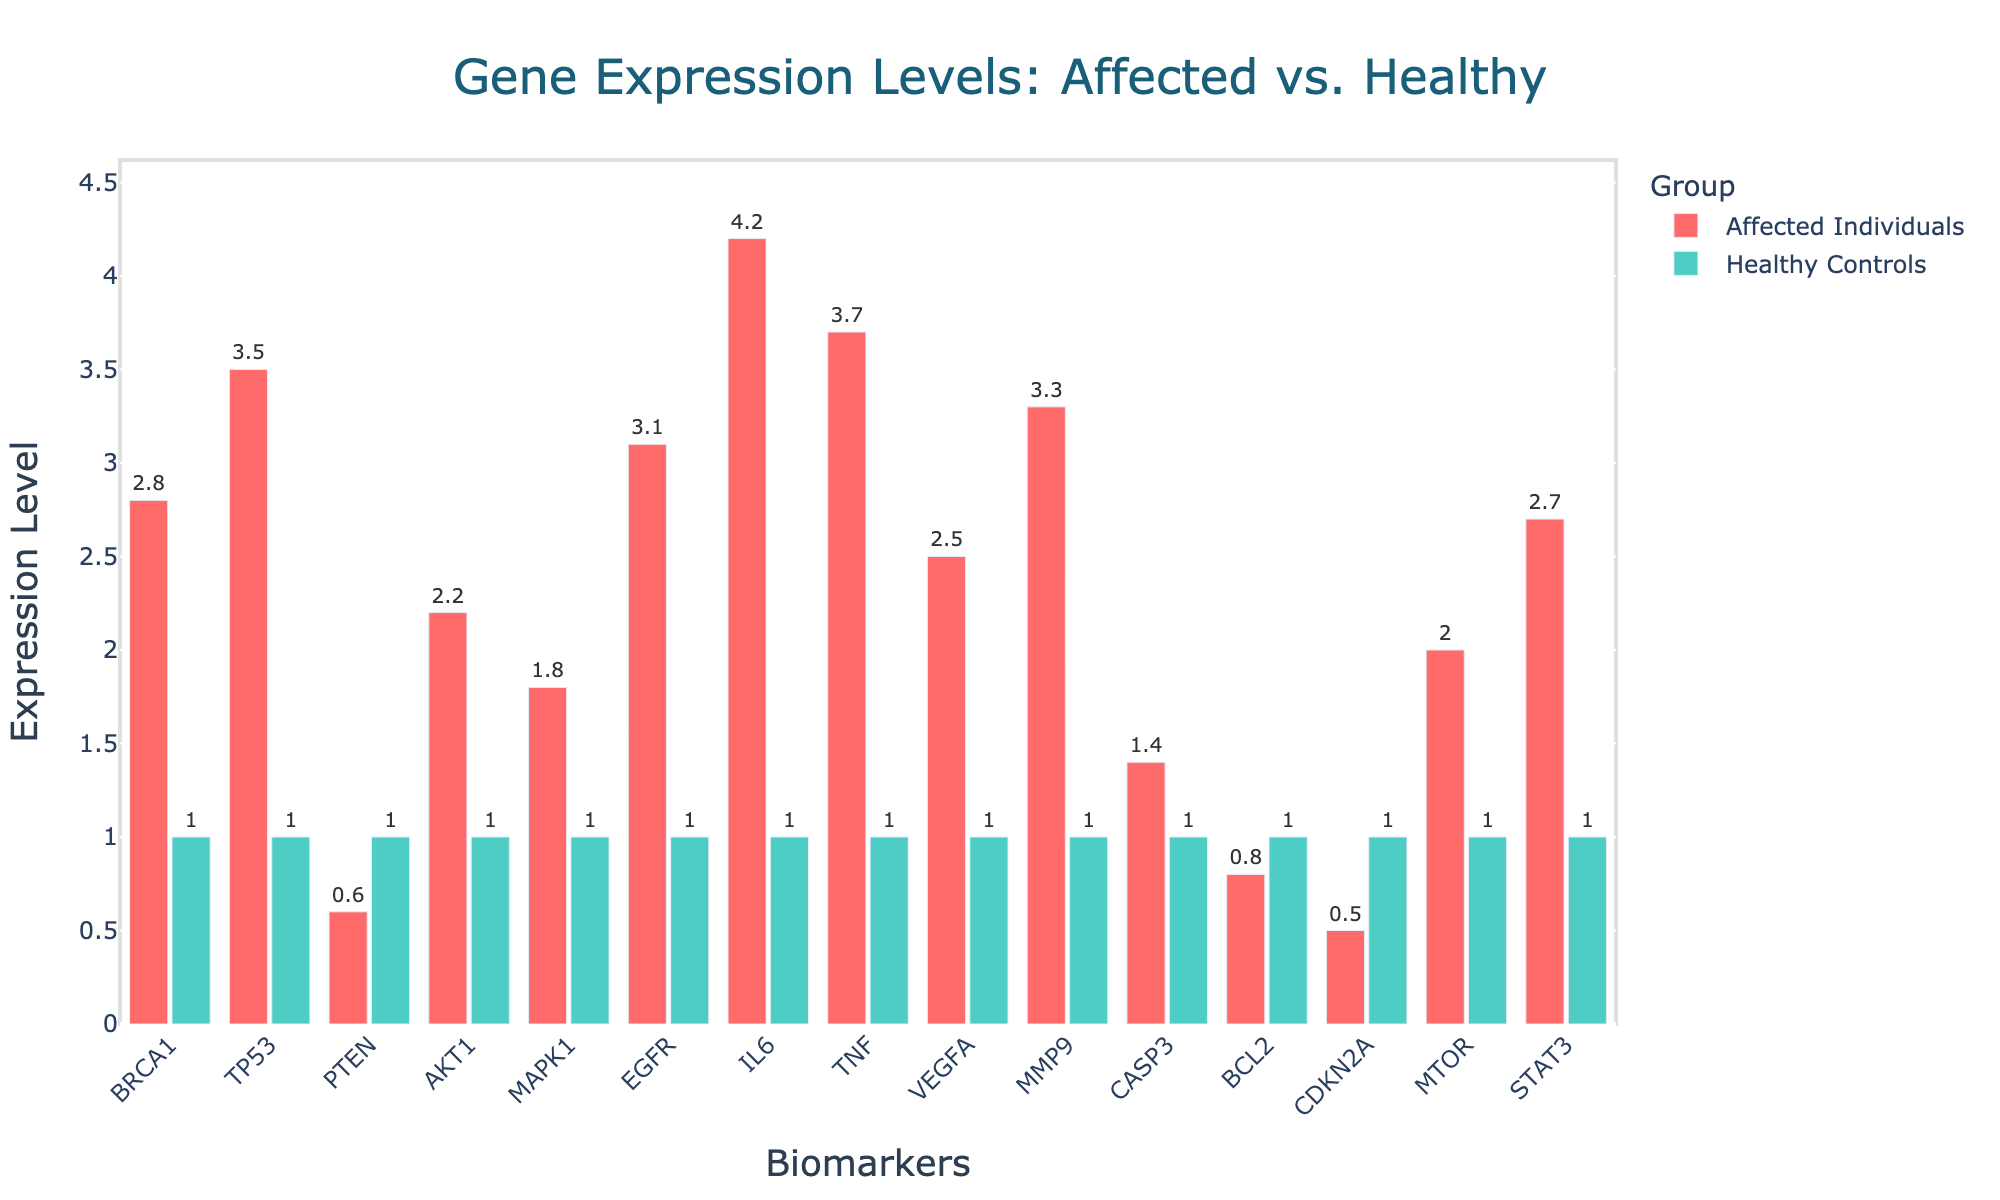What is the difference in gene expression levels of BRCA1 between affected individuals and healthy controls? The gene expression level for BRCA1 in affected individuals is 2.8, while in healthy controls it is 1.0. The difference is 2.8 - 1.0 = 1.8
Answer: 1.8 Which biomarker shows the highest gene expression level in affected individuals? By examining the heights of the bars representing affected individuals, IL6 has the highest bar corresponding to a gene expression level of 4.2
Answer: IL6 Are there any biomarkers where the gene expression level in healthy controls is higher than in affected individuals? By observing all the bars, PTEN (0.6 < 1.0), BCL2 (0.8 < 1.0), and CDKN2A (0.5 < 1.0) are biomarkers where the gene expression is higher in healthy controls
Answer: PTEN, BCL2, CDKN2A By how much does the gene expression level of EGFR in affected individuals exceed that in healthy controls? The gene expression level for EGFR in affected individuals is 3.1 while it is 1.0 in healthy controls. The excess is 3.1 - 1.0 = 2.1
Answer: 2.1 Which group has a more uniform gene expression level across the biomarkers, and how can you tell? The healthy controls show a more uniform gene expression level across the biomarkers because all bars for healthy controls are at the same height of 1.0, in contrast to the variable heights in affected individuals
Answer: Healthy controls What is the average gene expression level for biomarkers AKT1 and STAT3 in affected individuals? The gene expression levels for AKT1 and STAT3 are 2.2 and 2.7 respectively. The average is calculated as (2.2 + 2.7) / 2 = 2.45
Answer: 2.45 How many biomarkers have a gene expression level of at least 3.0 in affected individuals? By counting the bars that reach or exceed the height corresponding to 3.0, there are five biomarkers: TP53, EGFR, IL6, TNF, and MMP9
Answer: 5 Which biomarker shows the greatest decrease in gene expression levels when comparing affected individuals to healthy controls? By assessing the decrease, CDKN2A shows the greatest decrease as its value drops from 1.0 in healthy controls to 0.5 in affected individuals, a difference of -0.5
Answer: CDKN2A What are the two biomarkers with the closest gene expression levels in affected individuals? How close are they in value? By visually assessing the height of the bars and their respective values, BRCA1 (2.8) and STAT3 (2.7) are the closest with a difference of 2.8 - 2.7 = 0.1
Answer: BRCA1 and STAT3, 0.1 What is the sum of gene expression levels for BCL2 and CDKN2A in affected individuals? The gene expression levels are 0.8 for BCL2 and 0.5 for CDKN2A. The sum is 0.8 + 0.5 = 1.3
Answer: 1.3 